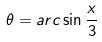<formula> <loc_0><loc_0><loc_500><loc_500>\theta = a r c \sin \frac { x } { 3 }</formula> 